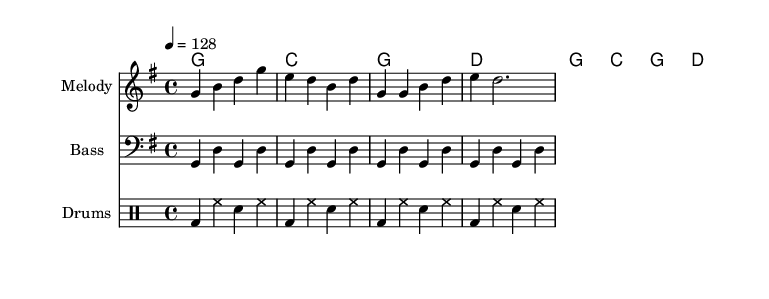What is the key signature of this music? The key signature is G major, which has one sharp (F#). This can be identified by looking at the key signature notation at the beginning of the staff.
Answer: G major What is the time signature of this piece? The time signature is 4/4, which means there are four beats in each measure and the quarter note gets one beat. This is denoted at the beginning of the sheet music in the time signature section.
Answer: 4/4 What is the tempo marking for this piece? The tempo marking is 128 beats per minute, indicated by the notation "4 = 128" at the beginning of the score. This shows the speed at which the piece should be played.
Answer: 128 How many measures are present in the melody? The melody section contains a total of four measures, which can be counted from the melody line as it has individual bars divided by vertical lines.
Answer: 4 What is the rhythmic pattern used for the drums? The drum pattern consists of bass drum, hi-hat, and snare drum played in a repetitive sequence, which includes variations of these elements across measures. It can be analyzed by looking at how many counts are associated with each drum in the measures.
Answer: Bass and snare beats What is the relationship between the melody and the harmony in this piece? The melody is designed to complement the chords in the harmony. Each melodic note corresponds with the harmonic support provided by the chords, creating a cohesive sound. This can be deduced by examining the pitches of the melody against the chord structure for each measure.
Answer: Complementary How is the bass line composed in this dance piece? The bass line alternates notes with a consistent rhythm, often repeating the root notes of the chords; it uses the same rhythmic structure as the melody to create a unified feel, which can be analyzed by looking at the bass notation below the melody.
Answer: Alternating notes 